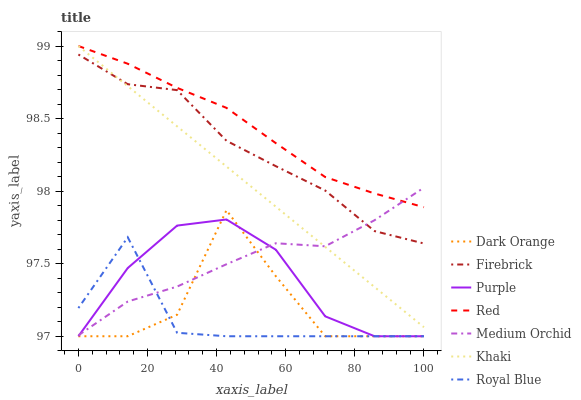Does Royal Blue have the minimum area under the curve?
Answer yes or no. Yes. Does Red have the maximum area under the curve?
Answer yes or no. Yes. Does Khaki have the minimum area under the curve?
Answer yes or no. No. Does Khaki have the maximum area under the curve?
Answer yes or no. No. Is Khaki the smoothest?
Answer yes or no. Yes. Is Dark Orange the roughest?
Answer yes or no. Yes. Is Purple the smoothest?
Answer yes or no. No. Is Purple the roughest?
Answer yes or no. No. Does Khaki have the lowest value?
Answer yes or no. No. Does Purple have the highest value?
Answer yes or no. No. Is Purple less than Red?
Answer yes or no. Yes. Is Khaki greater than Royal Blue?
Answer yes or no. Yes. Does Purple intersect Red?
Answer yes or no. No. 